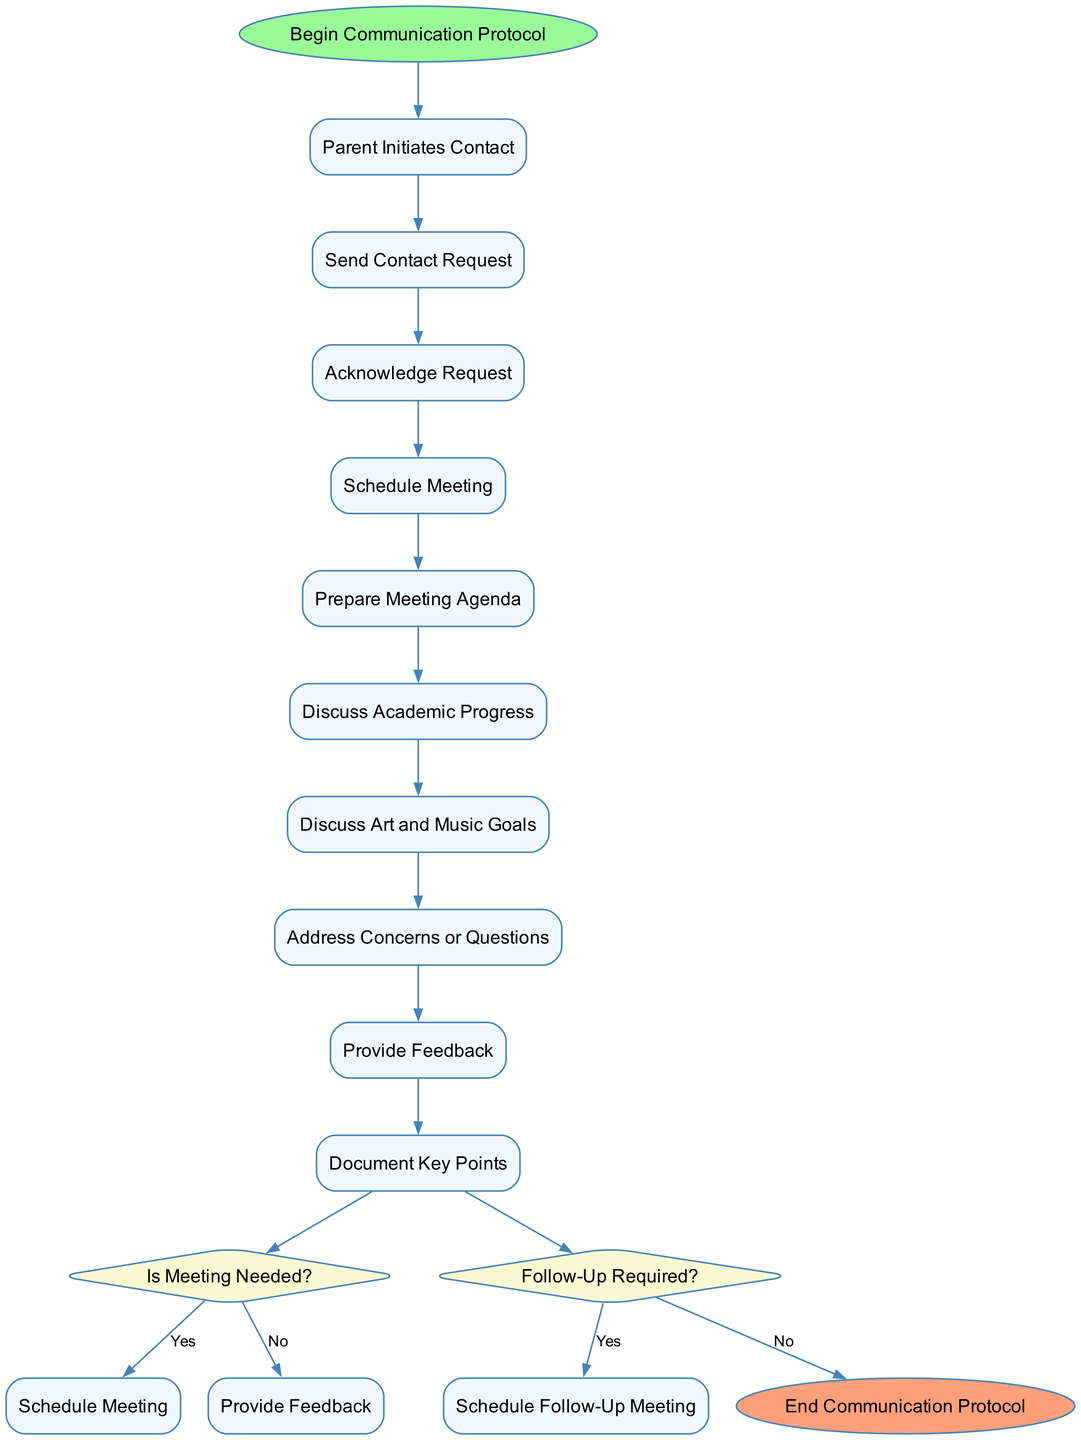What is the first activity in the communication protocol? The first activity is indicated directly after the "Begin Communication Protocol" node. It is the first rectangular node listed under activities, which is "Parent Initiates Contact."
Answer: Parent Initiates Contact What follows after "Schedule Meeting"? Following "Schedule Meeting," the next activity node is "Prepare Meeting Agenda," indicating the linear progression of activities in the protocol.
Answer: Prepare Meeting Agenda How many activities are there in total? The total number of activities is counted by listing each rectangular node found in the "activities" section, yielding a count of ten.
Answer: Ten Is “Discuss Academic Progress” directly connected to any decision? To determine this, we look for the flow from the activities to the decisions. The activity "Discuss Academic Progress" leads directly into the decision node "Is Meeting Needed?", confirming that there is a direct connection.
Answer: Yes What happens if the answer to "Is Meeting Needed?" is no? If the response is no, the flow directly leads to the node "Provide Feedback," indicating that no meeting is necessary at that point in the protocol.
Answer: Provide Feedback How many decision nodes are present in the diagram? The count of decision nodes is obtained by identifying each diamond-shaped node, which indicates choices; in this diagram, there are two decision nodes.
Answer: Two If a follow-up is required, what is the next activity? If the response to "Follow-Up Required?" is yes, the next step is to "Schedule Follow-Up Meeting," indicating that an additional interaction is warranted.
Answer: Schedule Follow-Up Meeting What colors are used for the start and end nodes? The start node is colored light green (#98FB98), and the end node is light coral (#FFA07A), which are distinct colors for the protocol's beginning and conclusion.
Answer: Light green and light coral 